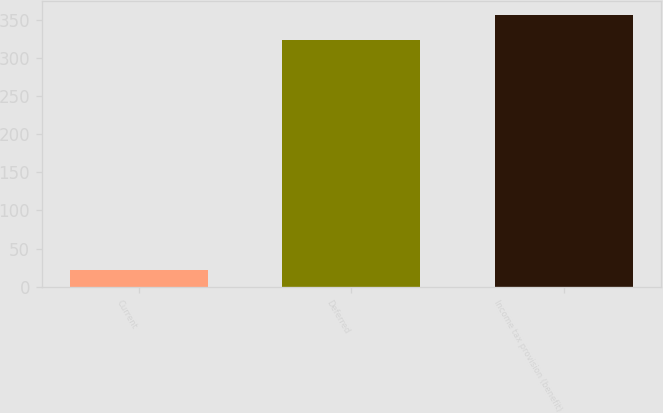Convert chart to OTSL. <chart><loc_0><loc_0><loc_500><loc_500><bar_chart><fcel>Current<fcel>Deferred<fcel>Income tax provision (benefit)<nl><fcel>22<fcel>324<fcel>356.4<nl></chart> 